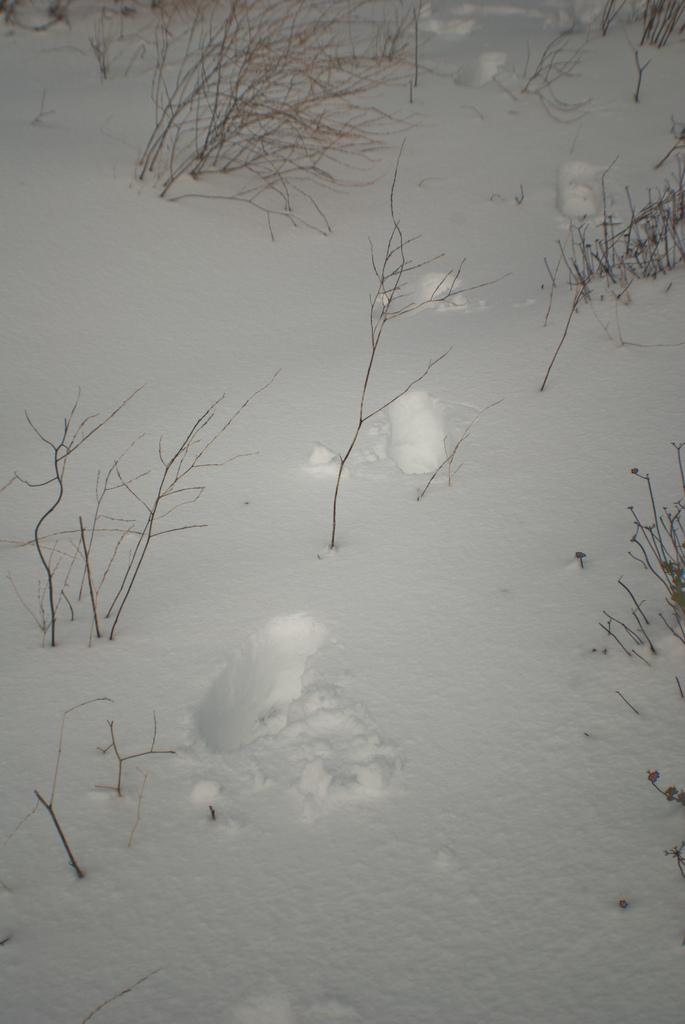What type of plants are on the ground in the image? There are dry plants on the ground in the image. What is covering the ground in the image? There is snow on the ground in the image. What type of banana can be seen growing in the image? There is no banana plant present in the image; it features dry plants and snow on the ground. What joke is being told by the foot in the image? There is no foot or joke present in the image. 